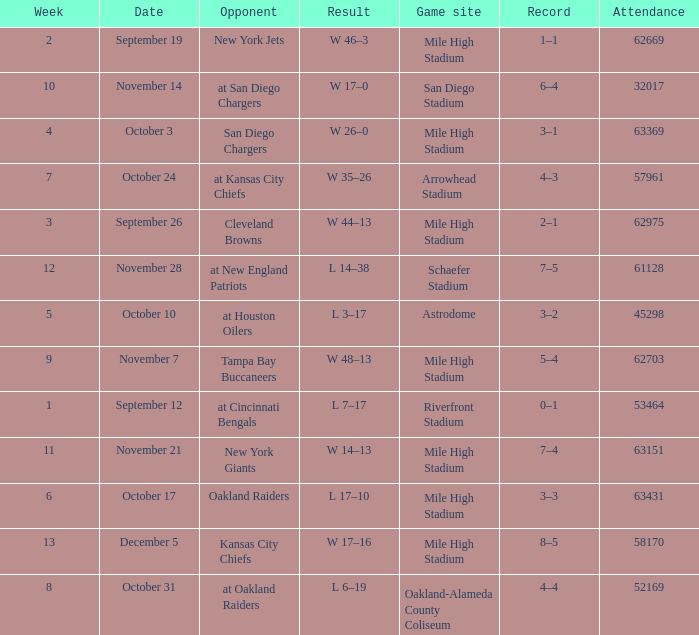In which week did the opponent face the new york jets? 2.0. 